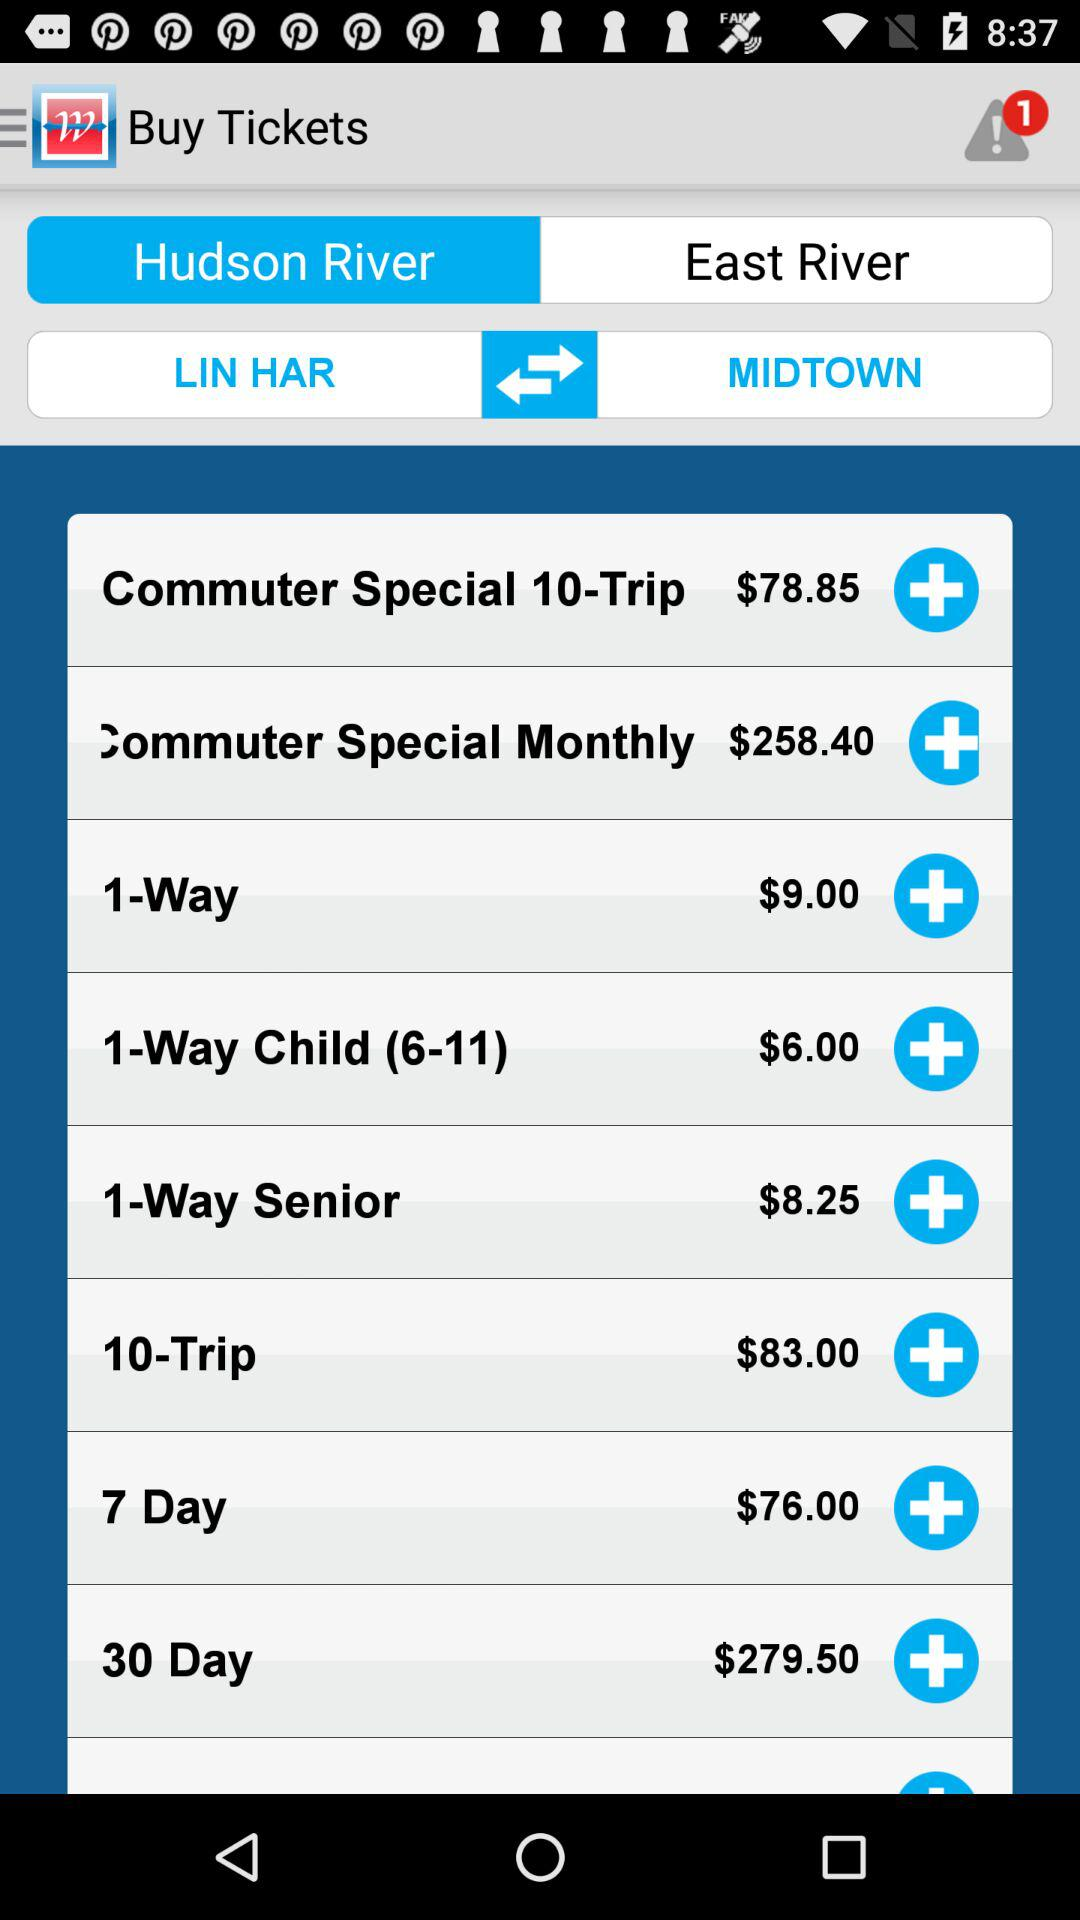How many notifications are unseen? There is 1 unseen notification. 